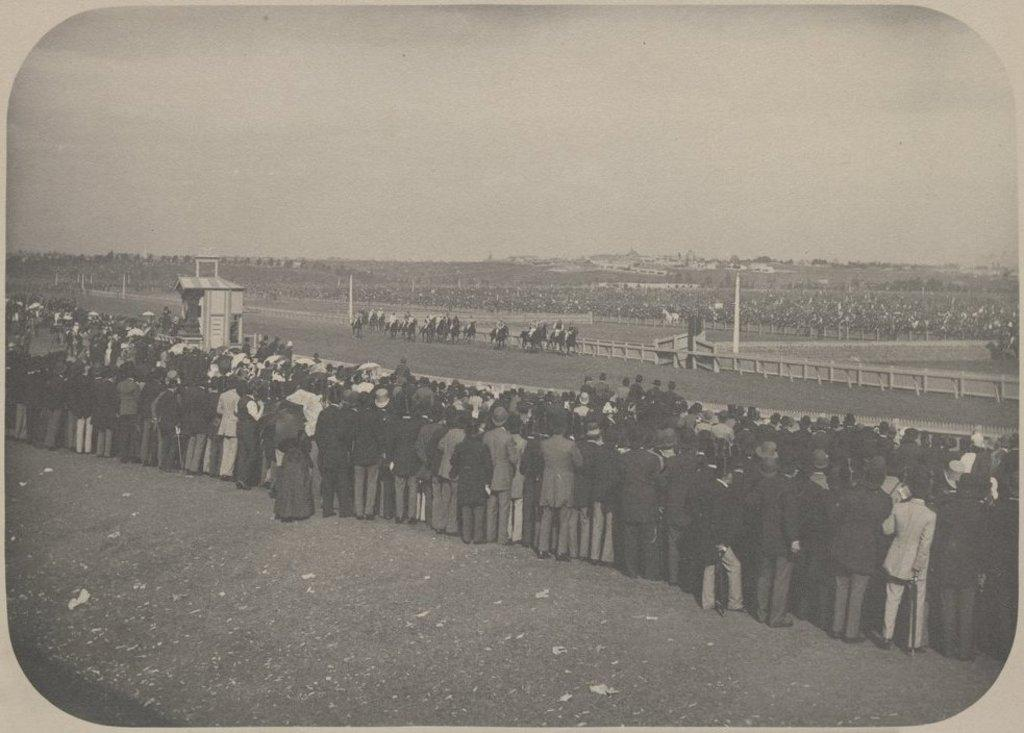What object is present in the image that typically holds a photo? There is a photo frame in the image. What is the color scheme of the photo in the frame? The photo is black and white. How many people can be seen in the image? There are many people in the image. What animals are present in the image? There are horses in the image. What structures can be seen in the image? There are poles in the image. What is visible in the background of the image? The sky is visible in the background of the image. Where is the sand located in the image? There is no sand present in the image. What type of basket is being used by the people in the image? There is no basket present in the image. 